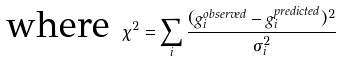Convert formula to latex. <formula><loc_0><loc_0><loc_500><loc_500>\text {where  } \chi ^ { 2 } = \sum _ { i } \frac { ( g _ { i } ^ { o b s e r v e d } - g _ { i } ^ { p r e d i c t e d } ) ^ { 2 } } { \sigma _ { i } ^ { 2 } }</formula> 